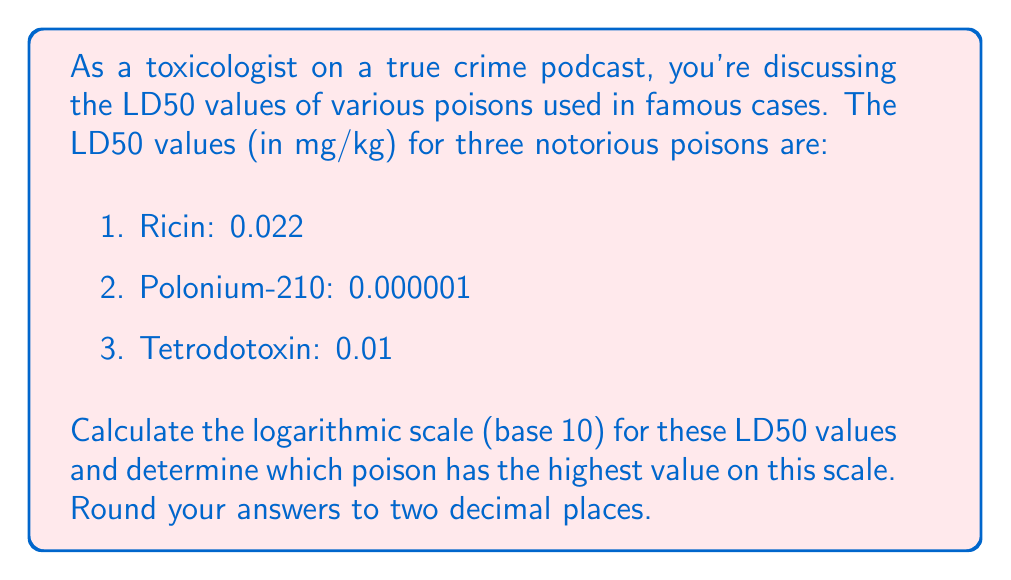Show me your answer to this math problem. To solve this problem, we need to calculate the logarithm (base 10) of each LD50 value and compare the results.

1. For Ricin:
   $$\log_{10}(0.022) = -1.66$$

2. For Polonium-210:
   $$\log_{10}(0.000001) = -6.00$$

3. For Tetrodotoxin:
   $$\log_{10}(0.01) = -2.00$$

The logarithmic scale allows us to compare these widely different values more easily. A higher value on this scale indicates a less potent poison (higher LD50), while a lower value indicates a more potent poison (lower LD50).

Comparing the results:
- Ricin: -1.66
- Polonium-210: -6.00
- Tetrodotoxin: -2.00

The highest value on this logarithmic scale is -1.66, corresponding to Ricin.
Answer: Ricin has the highest value (-1.66) on the logarithmic scale of LD50 values. 